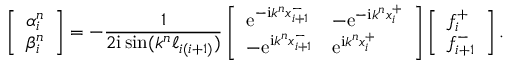Convert formula to latex. <formula><loc_0><loc_0><loc_500><loc_500>\left [ \begin{array} { l } { \alpha _ { i } ^ { n } } \\ { \beta _ { i } ^ { n } } \end{array} \right ] = - \frac { 1 } { 2 i \sin ( k ^ { n } \ell _ { i ( i + 1 ) } ) } \left [ \begin{array} { l l } { e ^ { - i k ^ { n } x _ { i + 1 } ^ { - } } } & { - e ^ { - i k ^ { n } x _ { i } ^ { + } } } \\ { - e ^ { i k ^ { n } x _ { i + 1 } ^ { - } } } & { e ^ { i k ^ { n } x _ { i } ^ { + } } } \end{array} \right ] \left [ \begin{array} { l } { f _ { i } ^ { + } } \\ { f _ { i + 1 } ^ { - } } \end{array} \right ] .</formula> 